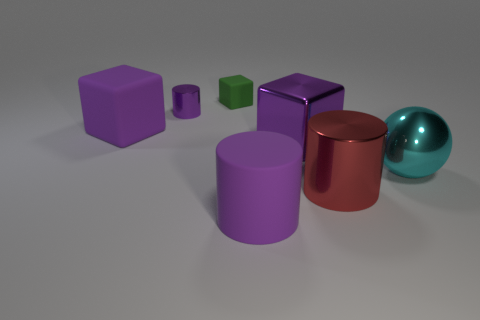Add 2 tiny blue rubber cylinders. How many objects exist? 9 Subtract all cylinders. How many objects are left? 4 Add 5 cyan things. How many cyan things are left? 6 Add 1 small purple metal cylinders. How many small purple metal cylinders exist? 2 Subtract 0 gray cylinders. How many objects are left? 7 Subtract all yellow metallic cylinders. Subtract all rubber cylinders. How many objects are left? 6 